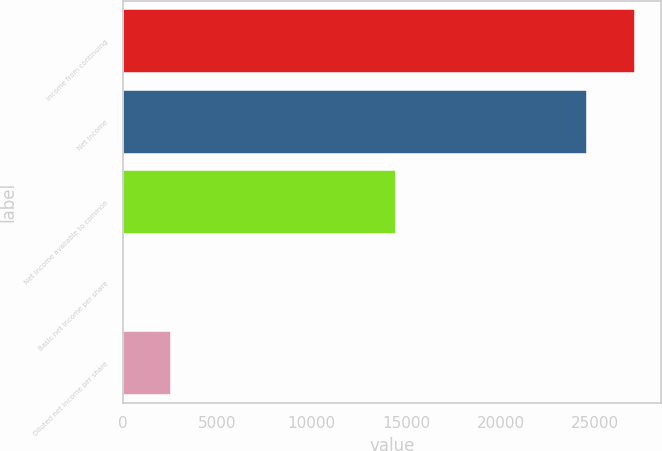<chart> <loc_0><loc_0><loc_500><loc_500><bar_chart><fcel>Income from continuing<fcel>Net income<fcel>Net income available to common<fcel>Basic net income per share<fcel>Diluted net income per share<nl><fcel>27121<fcel>24538<fcel>14436<fcel>0.2<fcel>2583.18<nl></chart> 